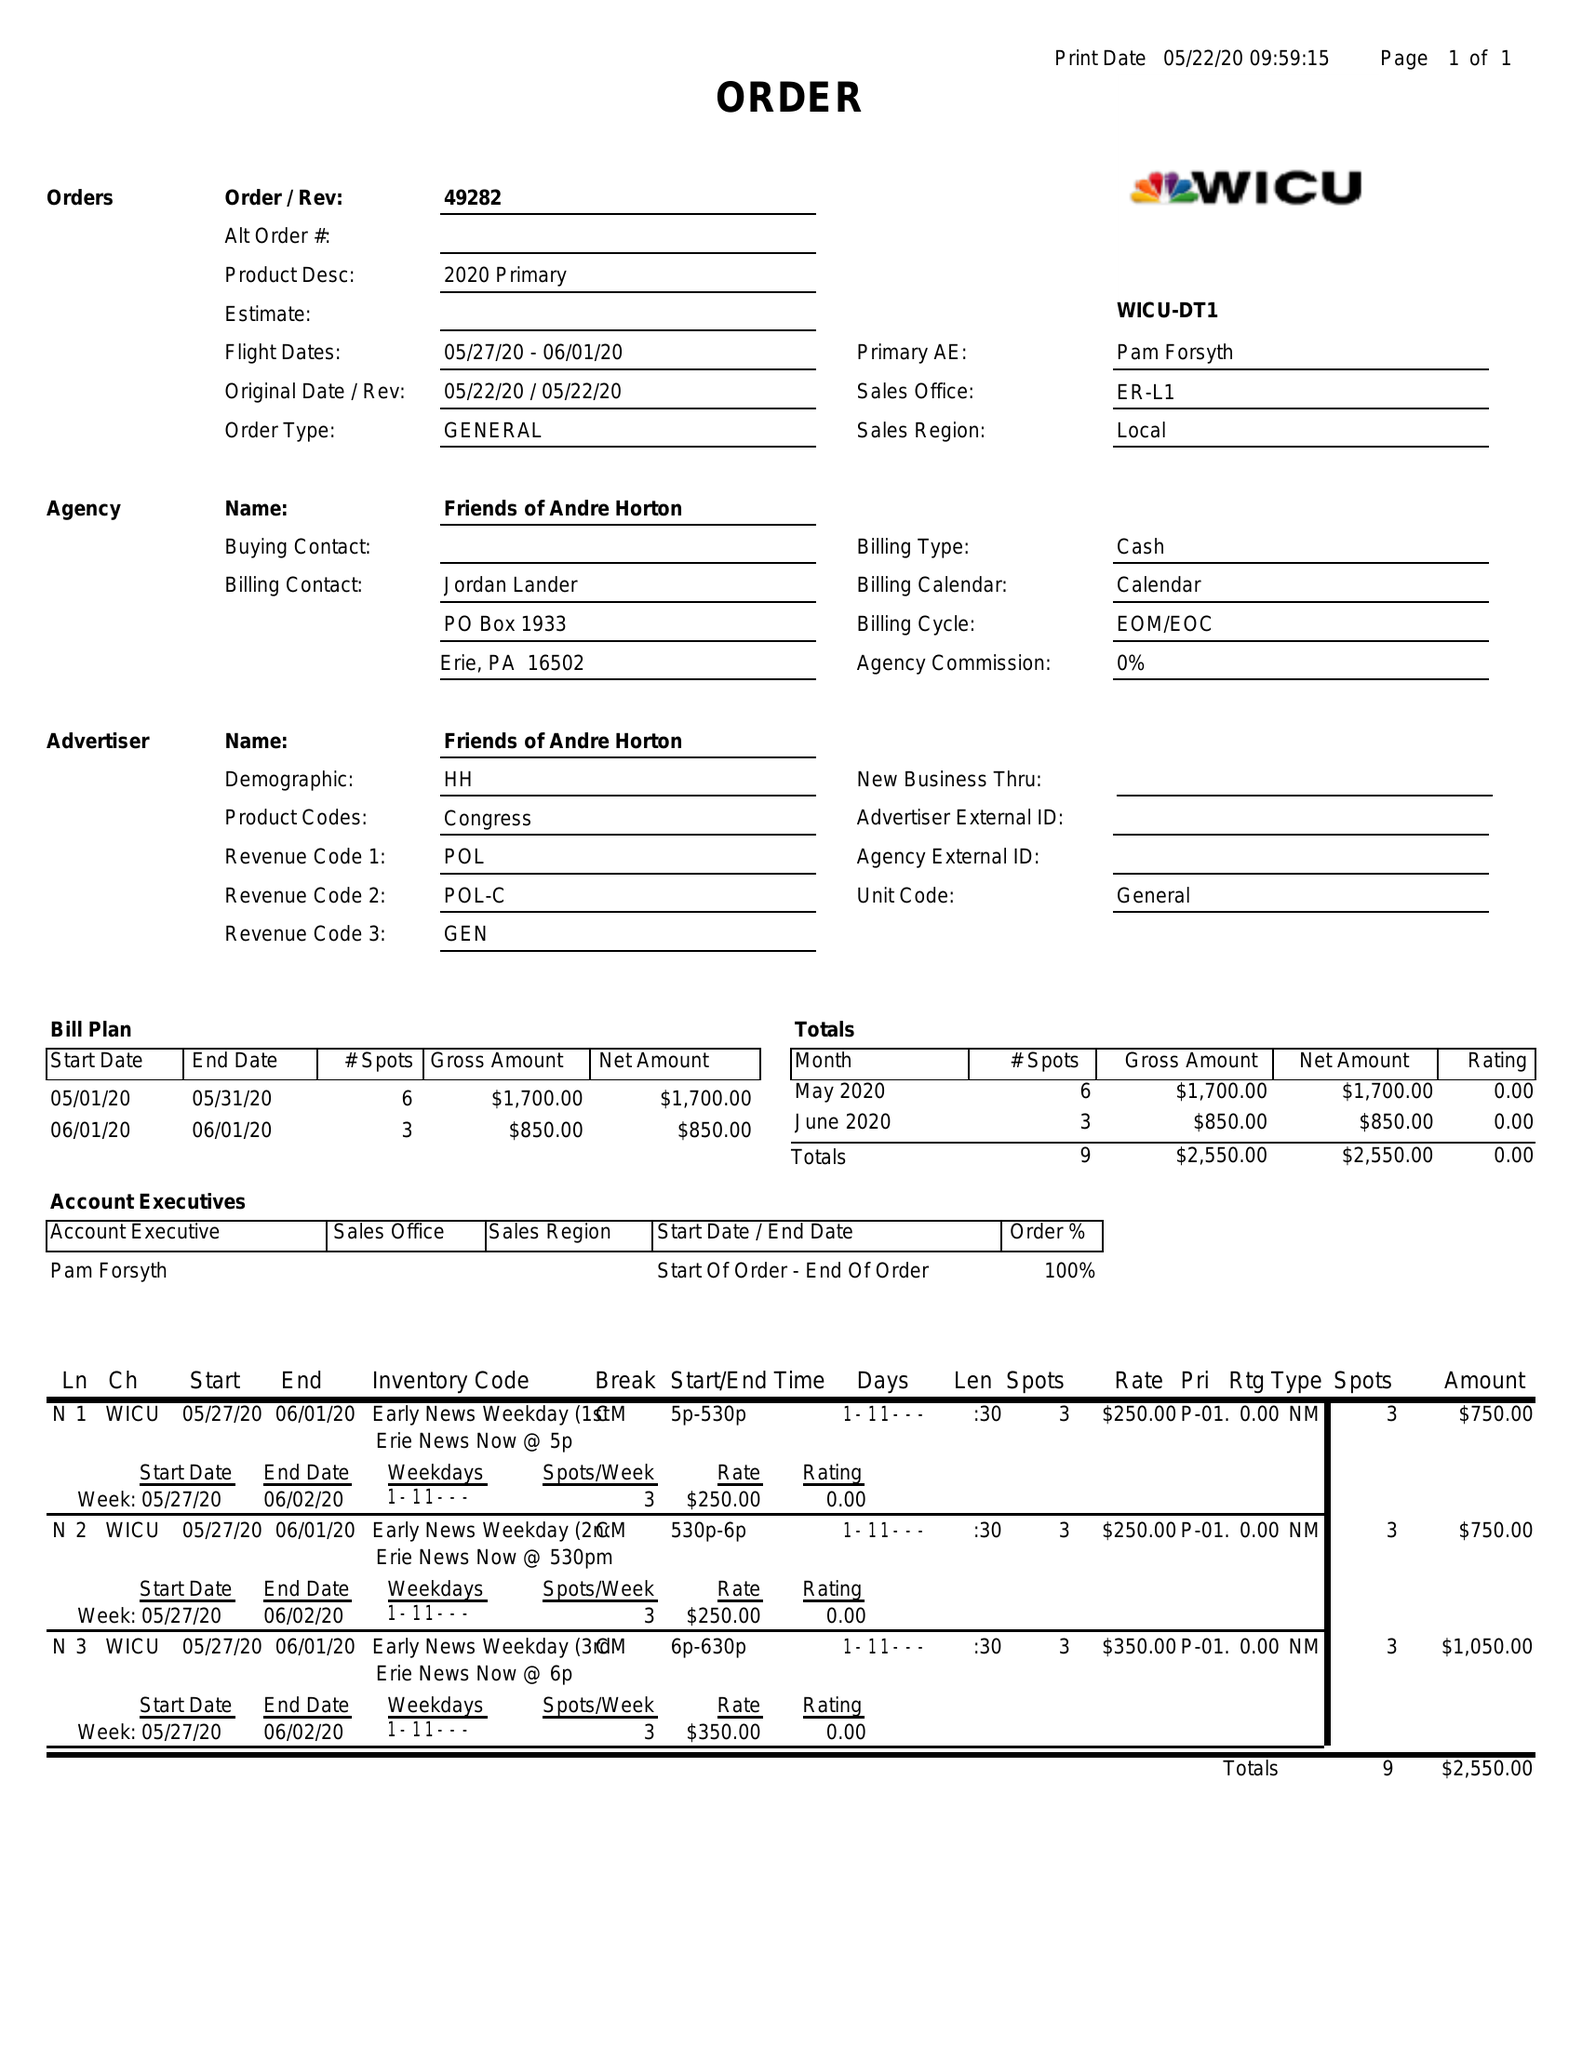What is the value for the advertiser?
Answer the question using a single word or phrase. FRIENDS OF ANDRE HORTON 